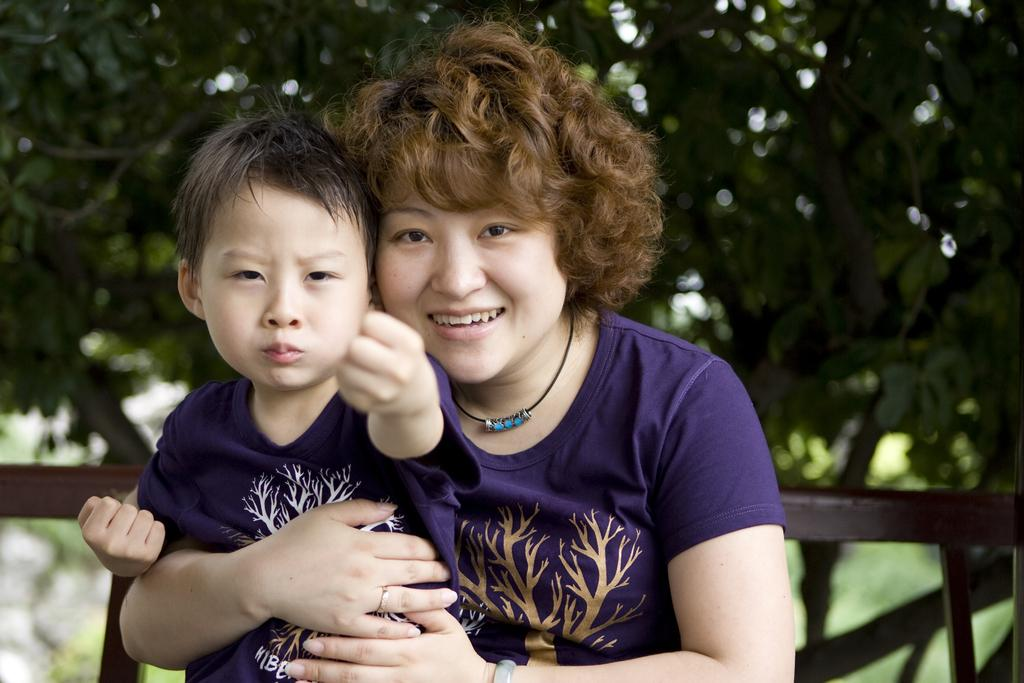What is the woman in the image doing? The woman is holding a child in the image. What can be seen in the background of the image? There is a wooden grill, trees, and the sky visible in the background of the image. How many spiders are crawling on the child's face in the image? There are no spiders present in the image, so it is not possible to determine how many might be crawling on the child's face. 